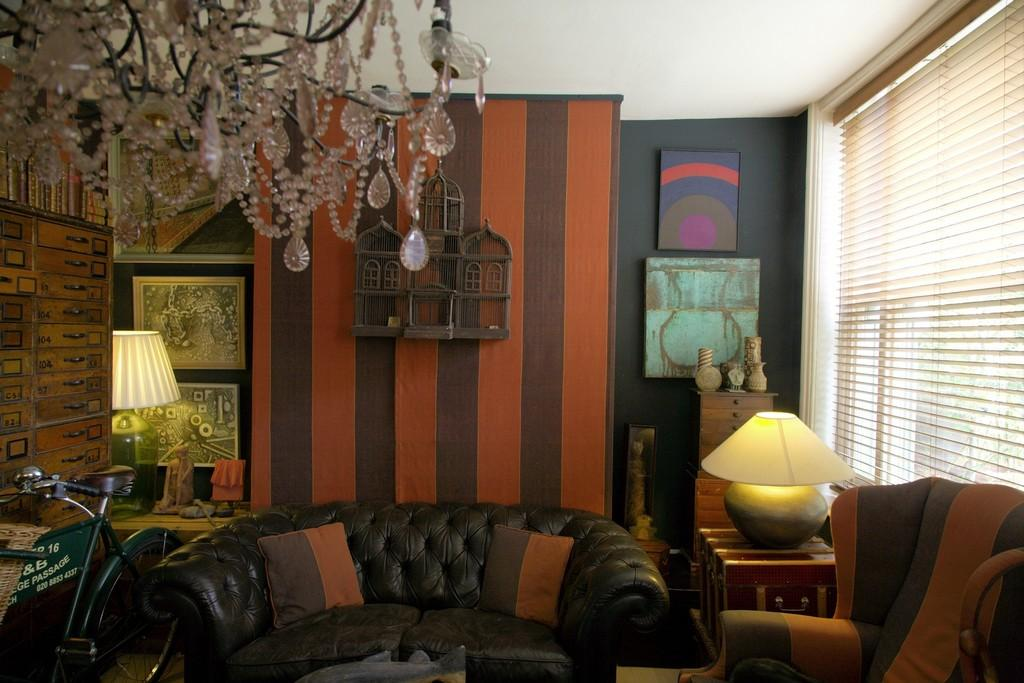What type of decorations can be seen in the image? There are wall hangings in the image. What type of seating is present in the image? There is a couch and a sofa in the image. What type of lighting is present in the image? There is a chandelier in the image. What type of window covering is present in the image? There is a window blind in the image. What type of furniture is present in the image? There is a table in the image. What type of accessory is present in the image? There is a bicycle lamp in the image. What type of behavior can be observed in the train in the image? There is no train present in the image, so no behavior can be observed. What type of point is visible in the image? There is no point visible in the image. 